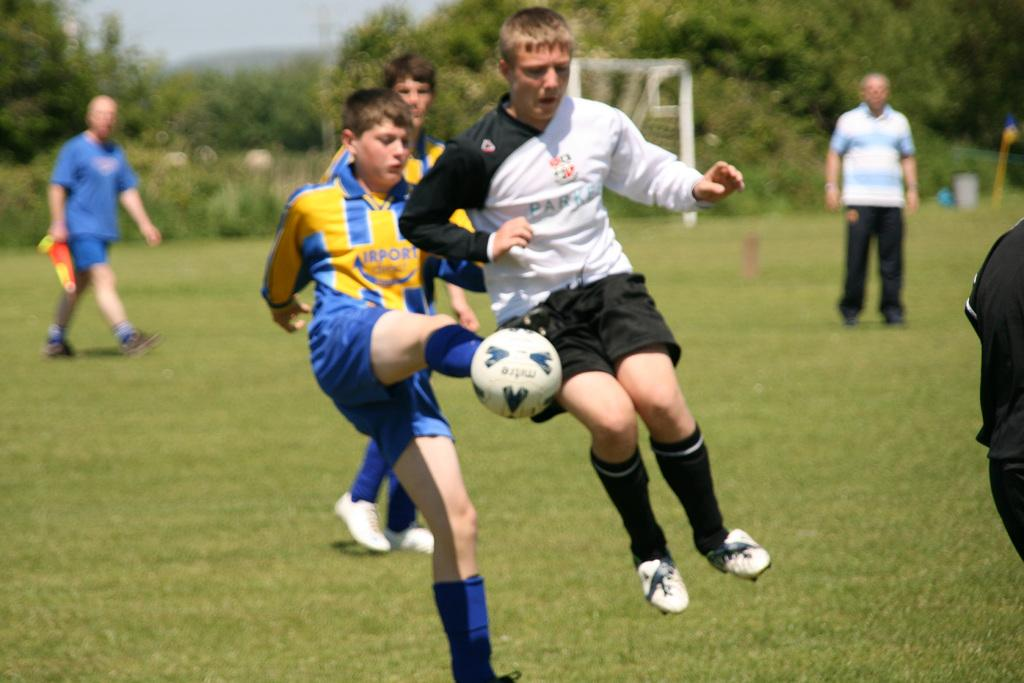What are the players in the image doing? The players in the image are holding a ball in the center of the image. Who else is present in the image besides the players? There is a person standing on the right side of the image. What can be seen in the background of the image? Trees and a net are visible in the background of the image. How many additional people are in the background of the image? There are two persons standing in the background of the image. What type of fire can be seen in the image? There is no fire present in the image. What reason might the players have for holding the ball in the image? The image does not provide any information about the players' reasons for holding the ball. 